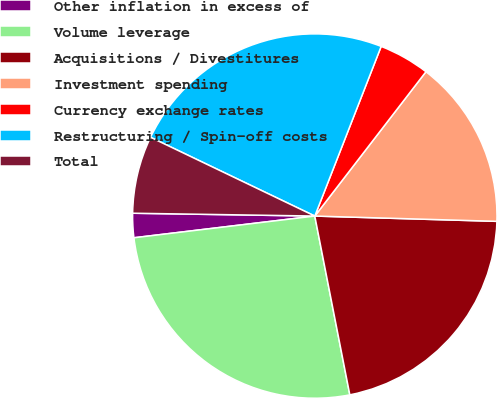Convert chart to OTSL. <chart><loc_0><loc_0><loc_500><loc_500><pie_chart><fcel>Other inflation in excess of<fcel>Volume leverage<fcel>Acquisitions / Divestitures<fcel>Investment spending<fcel>Currency exchange rates<fcel>Restructuring / Spin-off costs<fcel>Total<nl><fcel>2.15%<fcel>26.18%<fcel>21.46%<fcel>15.02%<fcel>4.51%<fcel>23.82%<fcel>6.87%<nl></chart> 